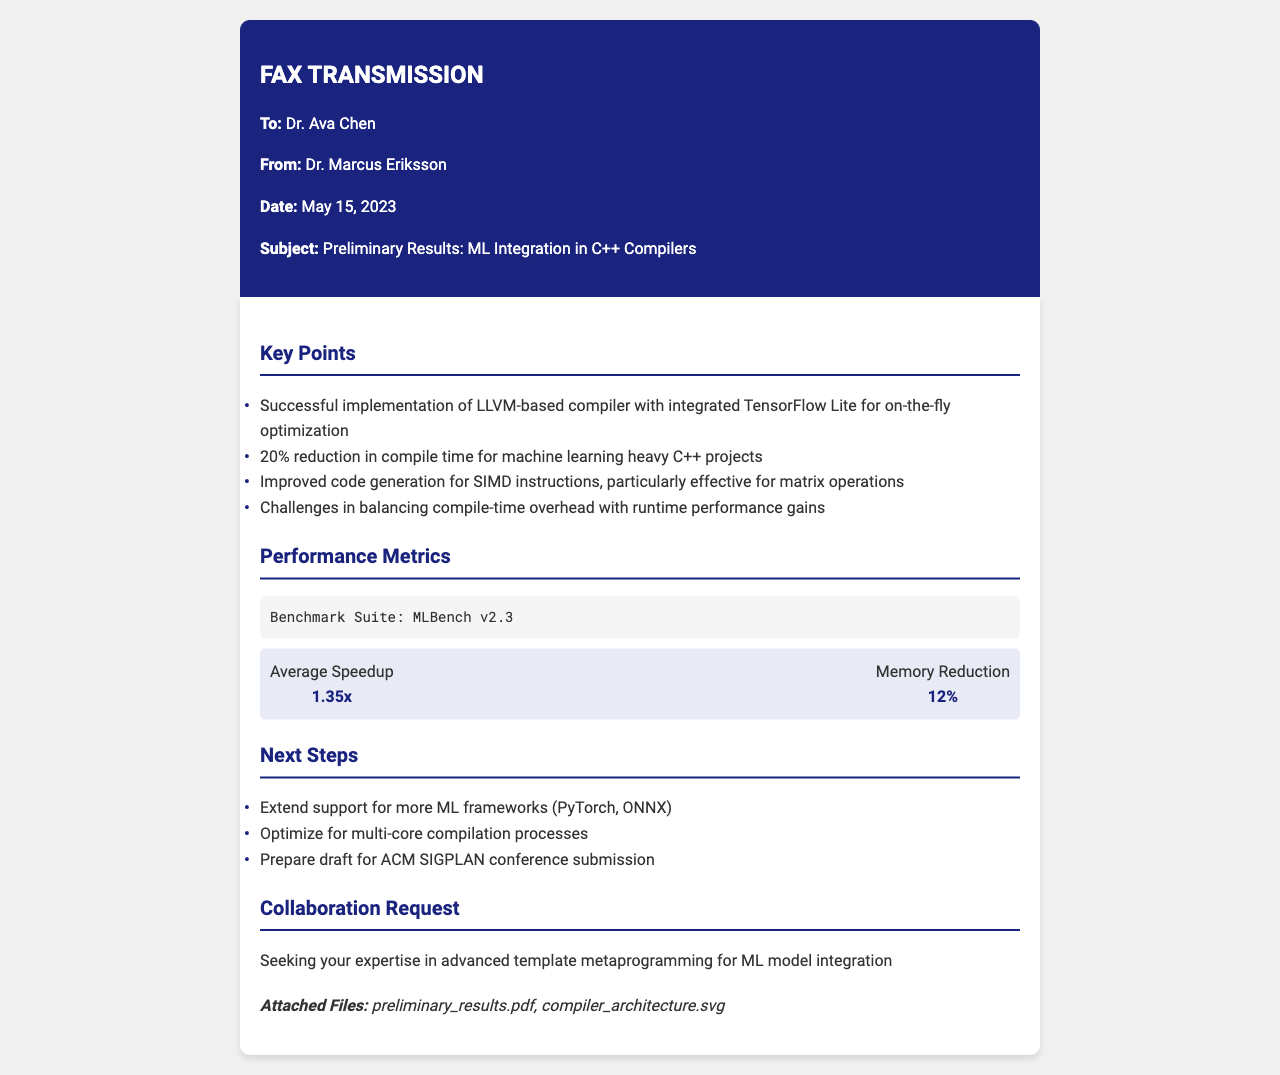what is the subject of the fax? The subject of the fax is explicitly stated in the document's header section.
Answer: Preliminary Results: ML Integration in C++ Compilers who is the sender of the fax? The sender's name is mentioned in the "From" section of the document.
Answer: Dr. Marcus Eriksson what percentage reduction in compile time was achieved? The reduction in compile time is listed under the key points section.
Answer: 20% what is the average speedup reported in the performance metrics? The average speedup is presented clearly in the performance metrics section.
Answer: 1.35x what is one of the challenges mentioned in the document? The challenges are directly quoted in the key points section of the fax.
Answer: Balancing compile-time overhead with runtime performance gains which benchmark suite was used? The name of the benchmark suite is indicated in the performance metrics section.
Answer: MLBench v2.3 what is a proposed next step in the project? The next steps are outlined in a separate section providing a list of actions to take.
Answer: Extend support for more ML frameworks who is being requested for collaboration? The collaboration request explicitly mentions who is sought for expertise.
Answer: Dr. Ava Chen 